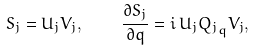Convert formula to latex. <formula><loc_0><loc_0><loc_500><loc_500>S _ { j } = U _ { j } V _ { j } , \quad \frac { \partial S _ { j } } { \partial q } = i \, U _ { j } { Q _ { j } } _ { q } V _ { j } ,</formula> 